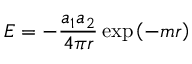<formula> <loc_0><loc_0><loc_500><loc_500>E = - { \frac { a _ { 1 } a _ { 2 } } { 4 \pi r } } \exp \left ( - m r \right )</formula> 